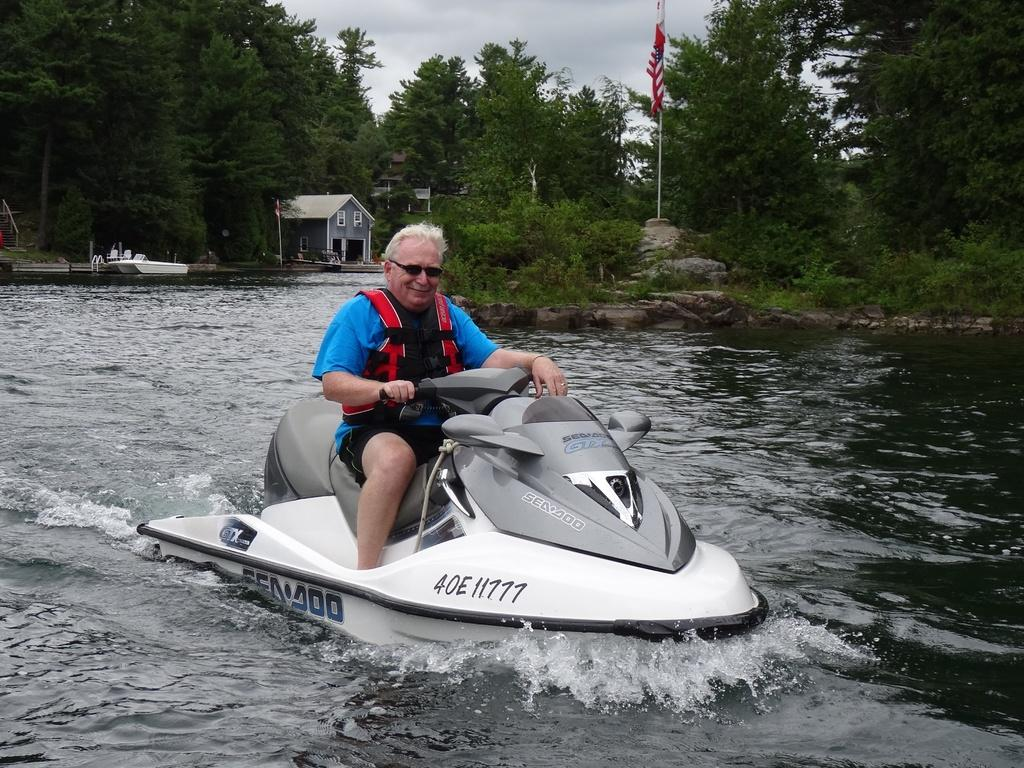<image>
Render a clear and concise summary of the photo. An older man riding a jet ski with the reg number 4OE11777. 